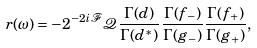Convert formula to latex. <formula><loc_0><loc_0><loc_500><loc_500>r ( \omega ) = - 2 ^ { - 2 i \mathcal { F } } \mathcal { Q } \frac { \Gamma ( d ) } { \Gamma ( d ^ { * } ) } \frac { \Gamma ( f _ { - } ) } { \Gamma ( g _ { - } ) } \frac { \Gamma ( f _ { + } ) } { \Gamma ( g _ { + } ) } ,</formula> 